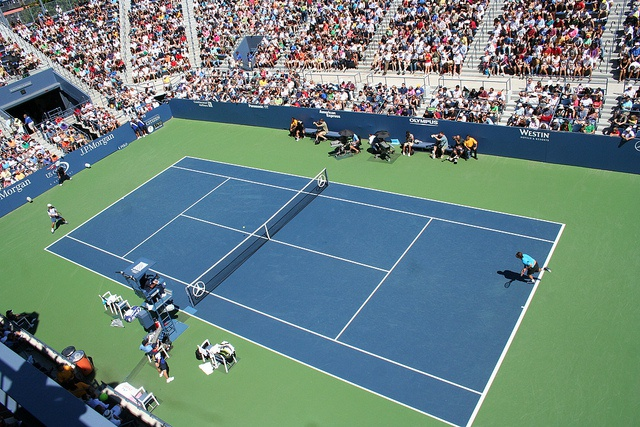Describe the objects in this image and their specific colors. I can see people in gray, green, black, olive, and white tones, chair in gray, white, darkgray, and green tones, people in gray, black, lightblue, and lightgray tones, people in gray, white, navy, black, and tan tones, and people in gray, black, darkgray, and ivory tones in this image. 